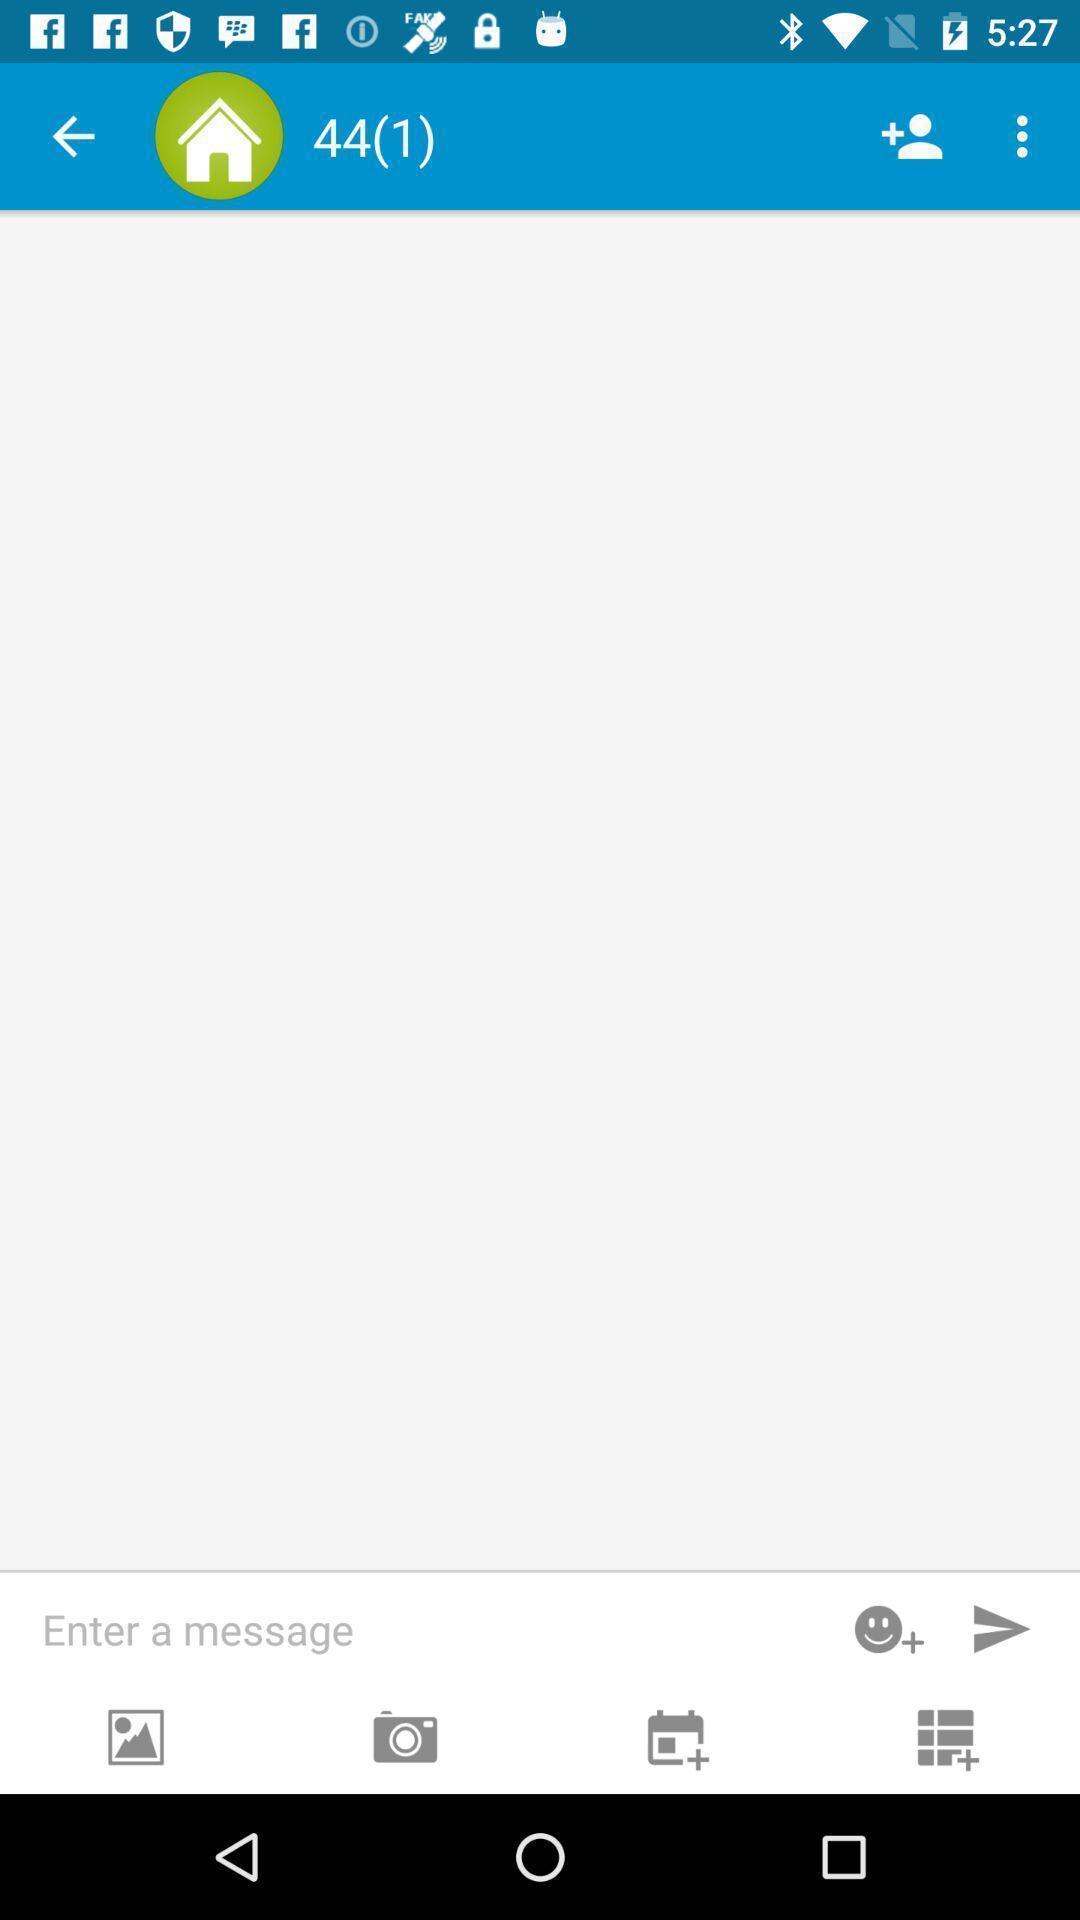What can you discern from this picture? Page showing the chat box to enter the message. 